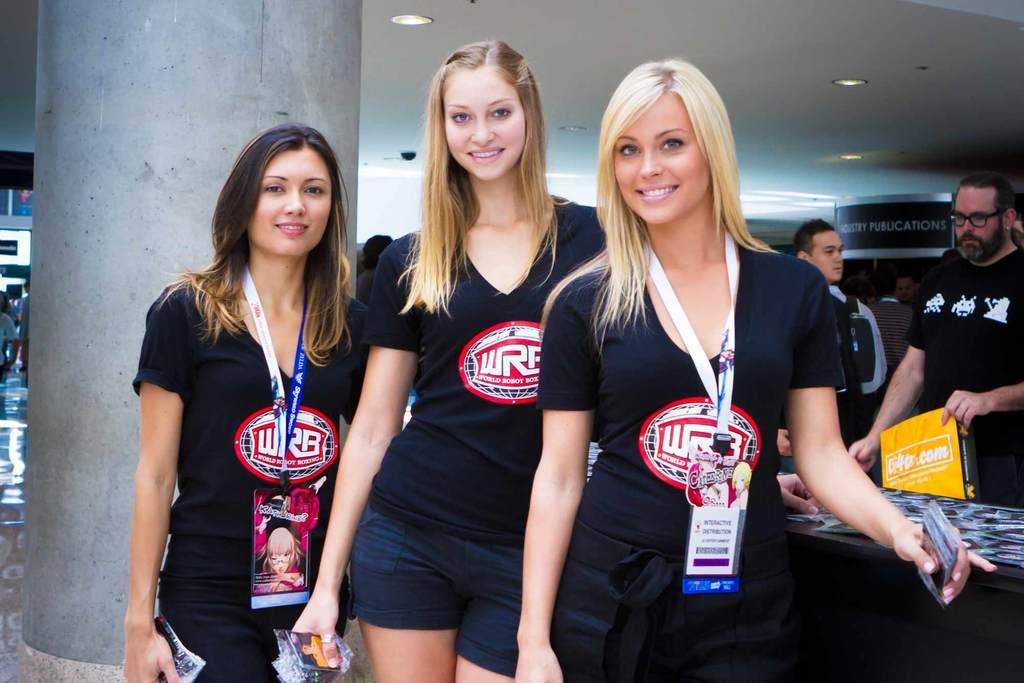<image>
Offer a succinct explanation of the picture presented. Three women wear black WRB (World Robot Boxing) shirts 